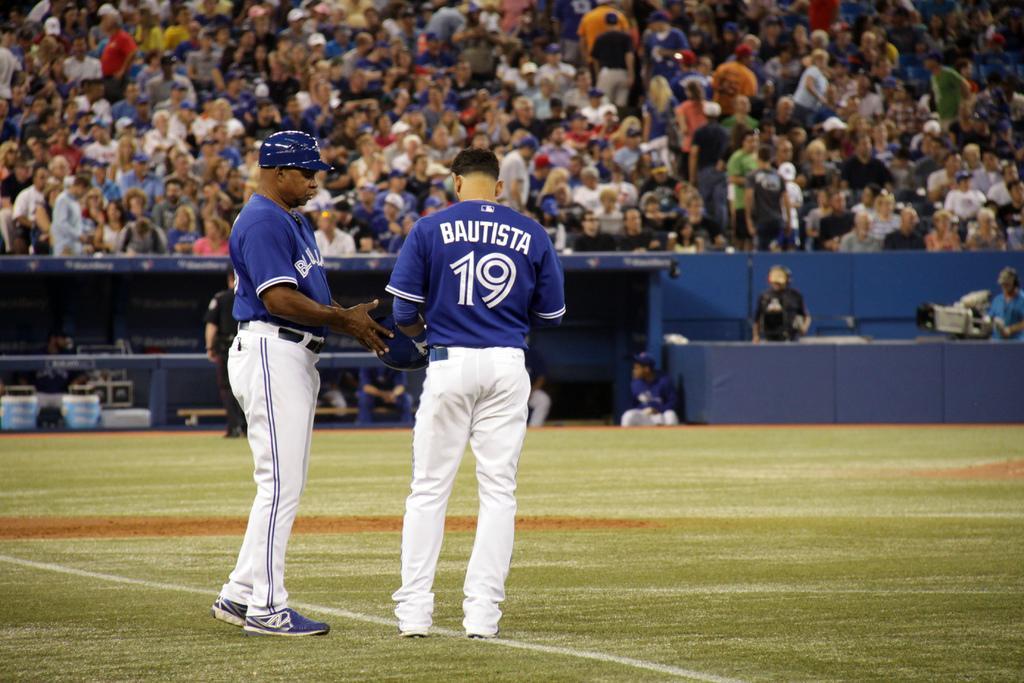Please provide a concise description of this image. In this image there are two baseball players standing on the ground. In the background there are so many spectators who are sitting in the chairs and watching them. On the right side there are cameraman's. Beside them there are few other people sitting in the dugout. 